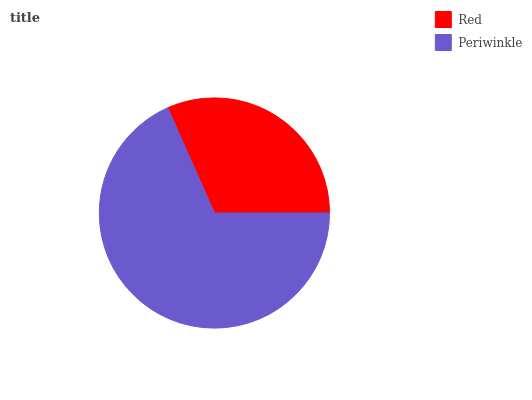Is Red the minimum?
Answer yes or no. Yes. Is Periwinkle the maximum?
Answer yes or no. Yes. Is Periwinkle the minimum?
Answer yes or no. No. Is Periwinkle greater than Red?
Answer yes or no. Yes. Is Red less than Periwinkle?
Answer yes or no. Yes. Is Red greater than Periwinkle?
Answer yes or no. No. Is Periwinkle less than Red?
Answer yes or no. No. Is Periwinkle the high median?
Answer yes or no. Yes. Is Red the low median?
Answer yes or no. Yes. Is Red the high median?
Answer yes or no. No. Is Periwinkle the low median?
Answer yes or no. No. 